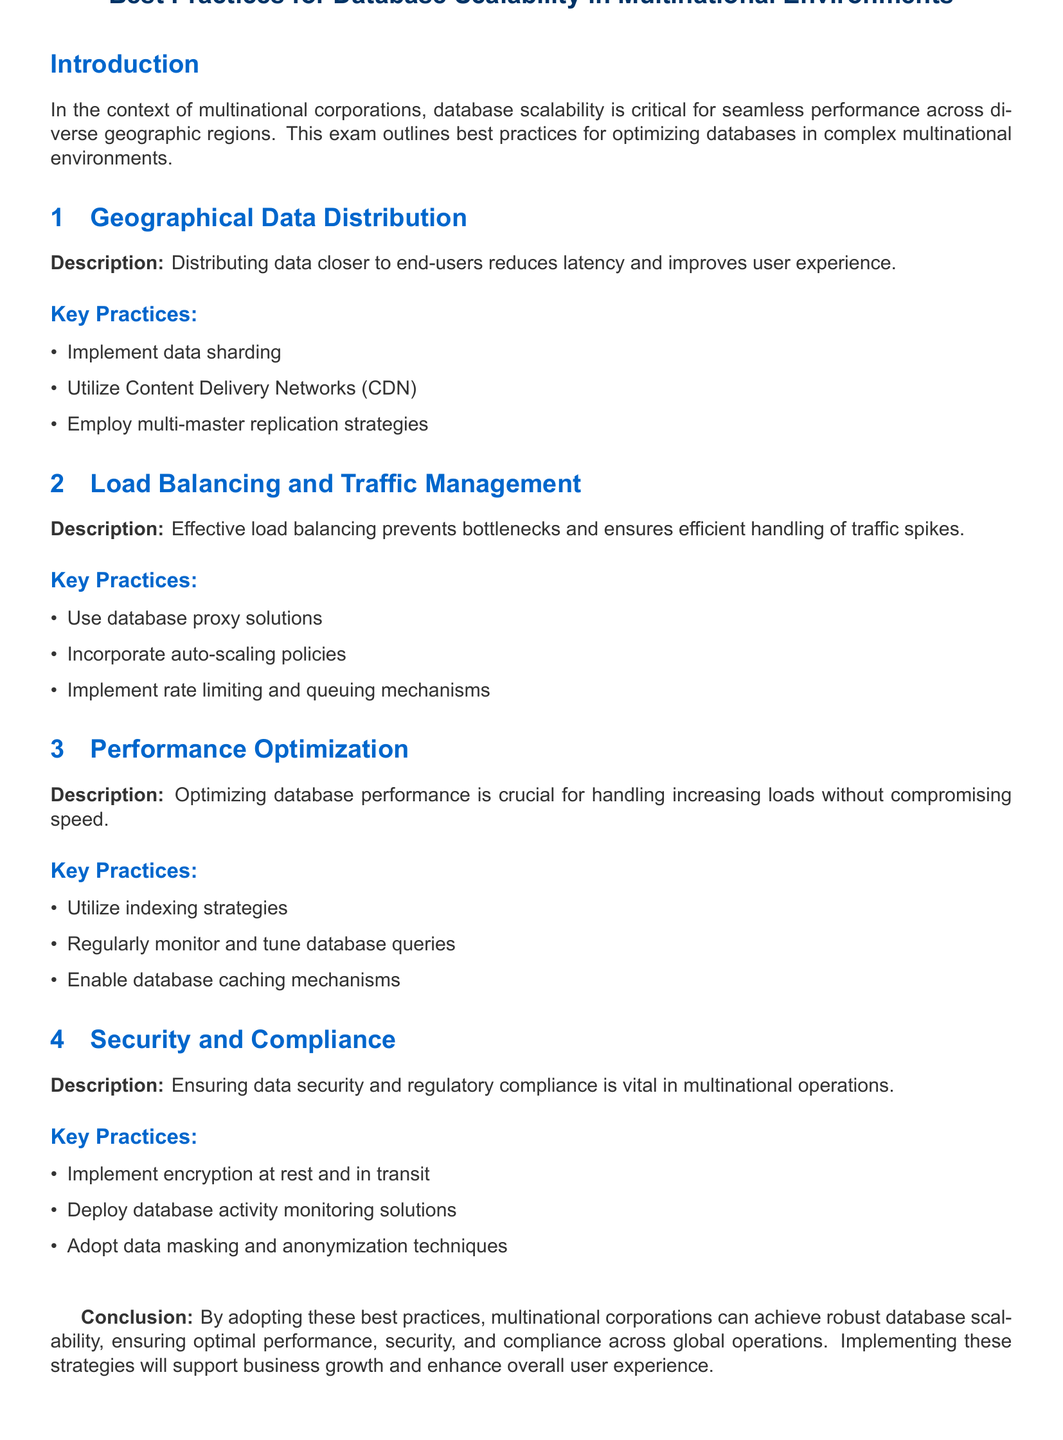what is the title of the document? The title of the document is displayed in the header and summarizes the key focus.
Answer: Best Practices for Database Scalability in Multinational Environments how many key practices are listed under Geographical Data Distribution? The section lists specific key practices aimed at optimizing data distribution for latency reduction.
Answer: 3 name one key practice for Load Balancing and Traffic Management. This practice is specifically identified to prevent performance issues during traffic spikes.
Answer: Use database proxy solutions what is the focus of the Performance Optimization section? The section highlights the importance of strategies to maintain performance as database loads increase.
Answer: Optimizing database performance which security measure is recommended for regulatory compliance? The document specifies practices that ensure security in multinational operations while adhering to regulations.
Answer: Implement encryption at rest and in transit how does the conclusion summarize the document's overall strategy? The conclusion reflects the outcomes of implementing the previously mentioned practices.
Answer: Achieve robust database scalability which practice relates to data privacy in the Security and Compliance section? This practice addresses the anonymization of data to protect sensitive information.
Answer: Adopt data masking and anonymization techniques what is suggested to reduce latency for end-users? The document includes specific strategies aimed at closer data access for users.
Answer: Distributing data closer to end-users 